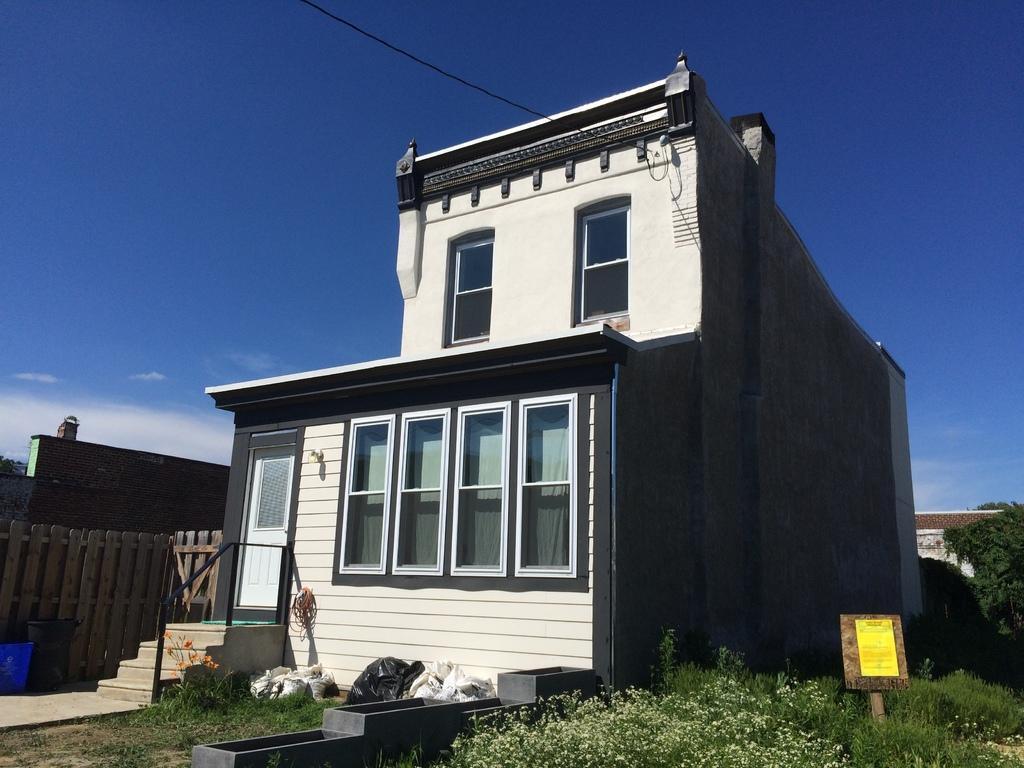How would you summarize this image in a sentence or two? In this picture I can see a building and a house in the back. I can see trees, plants and I can see a compound wall and a blue cloudy sky and I can see a paper on the board with some text. 